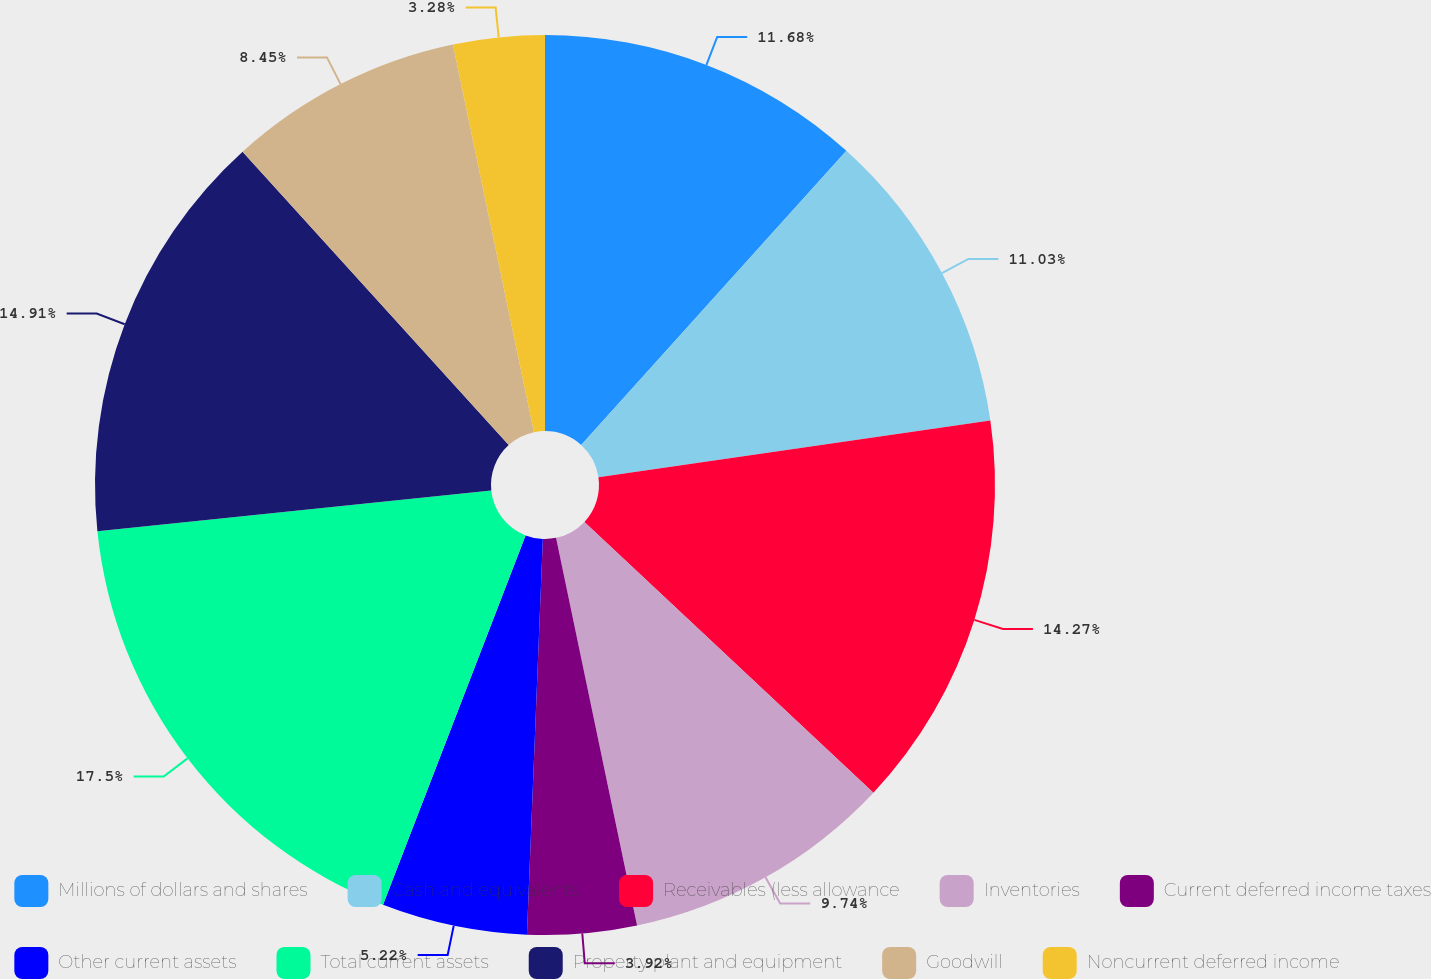Convert chart to OTSL. <chart><loc_0><loc_0><loc_500><loc_500><pie_chart><fcel>Millions of dollars and shares<fcel>Cash and equivalents<fcel>Receivables (less allowance<fcel>Inventories<fcel>Current deferred income taxes<fcel>Other current assets<fcel>Total current assets<fcel>Property plant and equipment<fcel>Goodwill<fcel>Noncurrent deferred income<nl><fcel>11.68%<fcel>11.03%<fcel>14.27%<fcel>9.74%<fcel>3.92%<fcel>5.22%<fcel>17.5%<fcel>14.91%<fcel>8.45%<fcel>3.28%<nl></chart> 